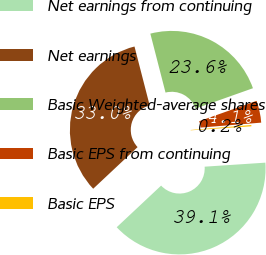Convert chart. <chart><loc_0><loc_0><loc_500><loc_500><pie_chart><fcel>Net earnings from continuing<fcel>Net earnings<fcel>Basic Weighted-average shares<fcel>Basic EPS from continuing<fcel>Basic EPS<nl><fcel>39.07%<fcel>32.98%<fcel>23.59%<fcel>4.13%<fcel>0.24%<nl></chart> 